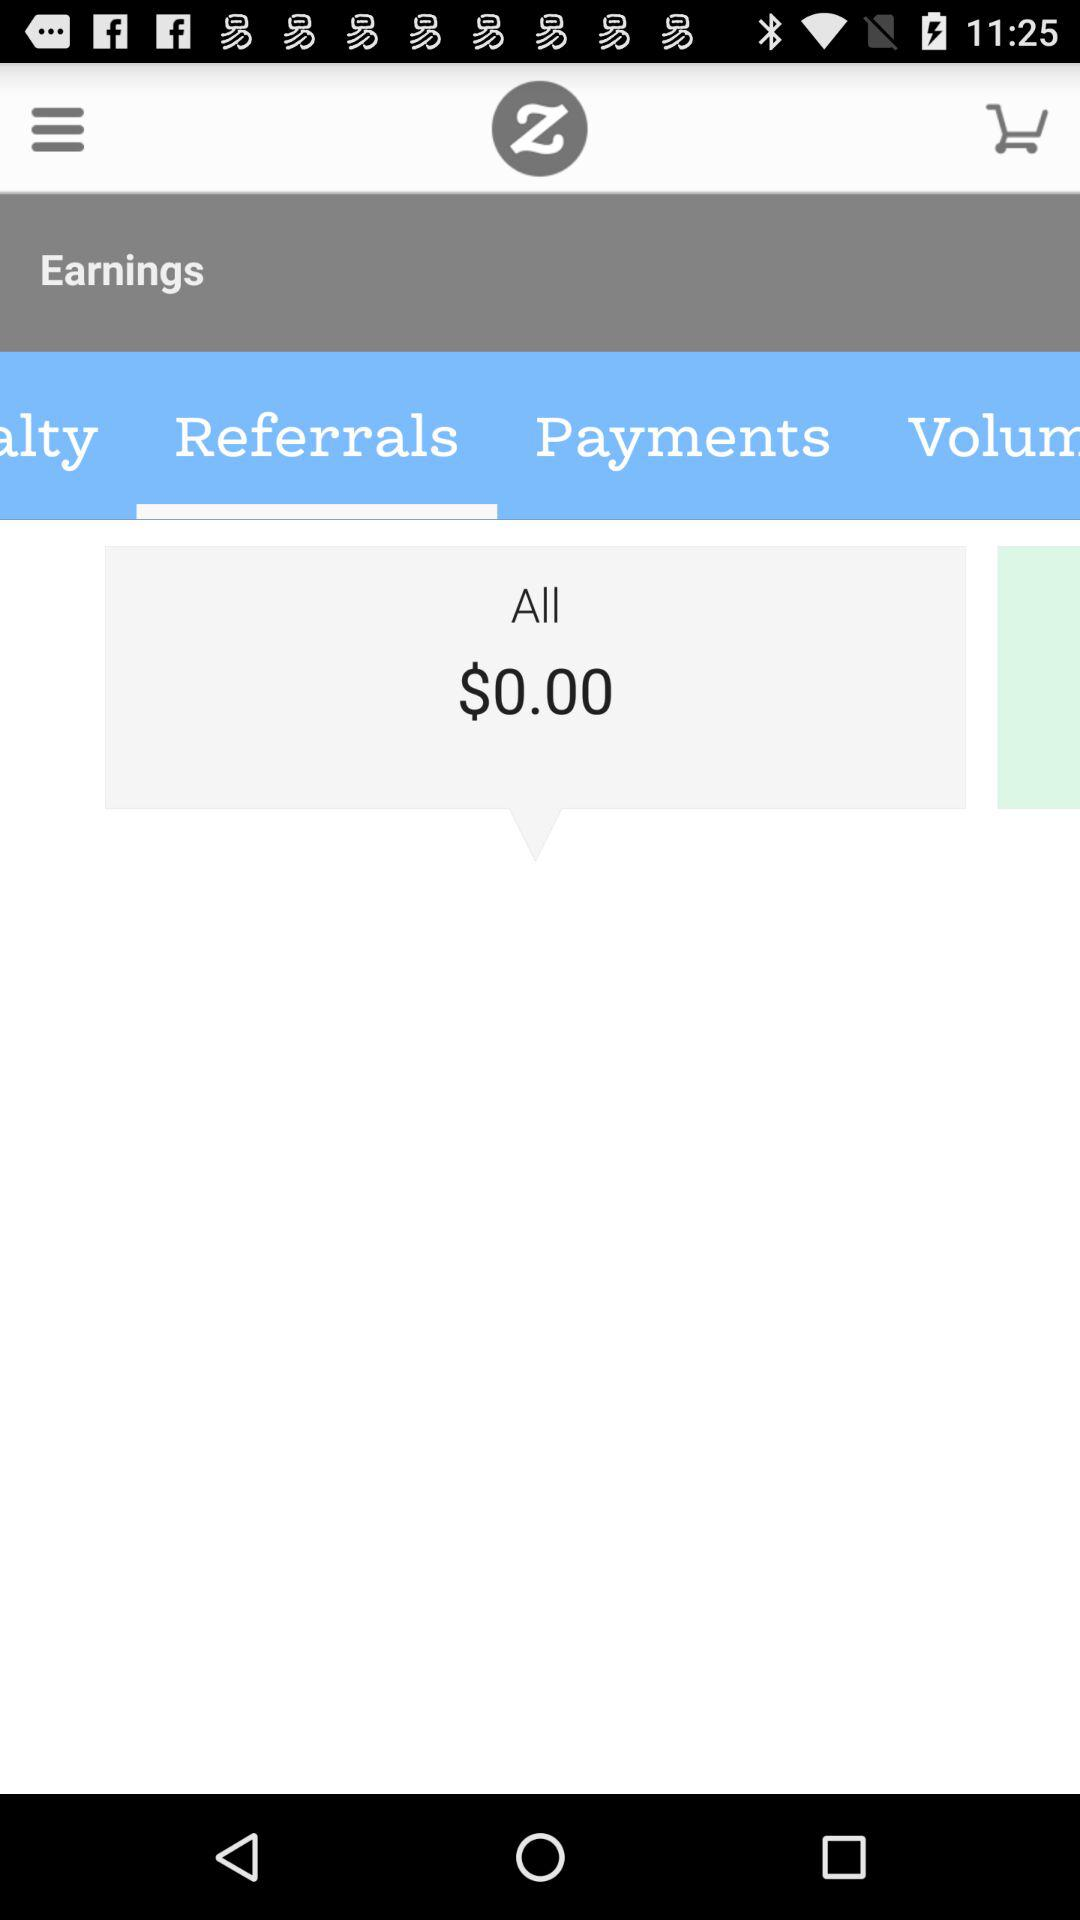How much money do I have in total?
Answer the question using a single word or phrase. $0.00 